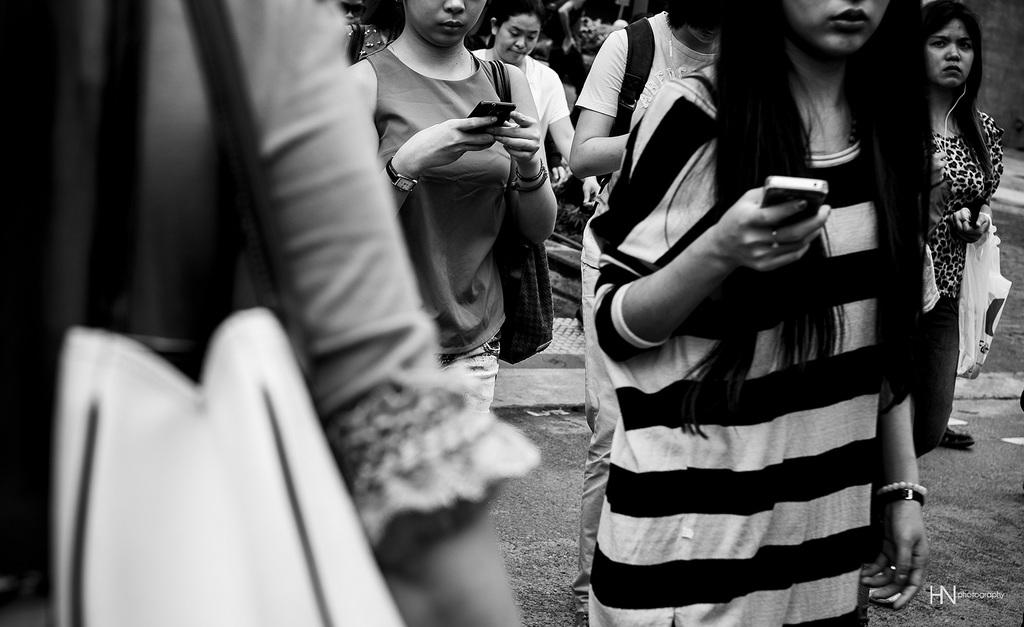How many people are in the group in the image? There is a group of persons in the image, but the exact number is not specified. What are some people in the group doing? Some people in the group are holding objects. What type of accessory can be seen on some people in the group? Some people in the group are wearing handbags. Can you tell me how many steps the rabbit takes in the image? There is no rabbit present in the image, so it is not possible to determine the number of steps it might take. 